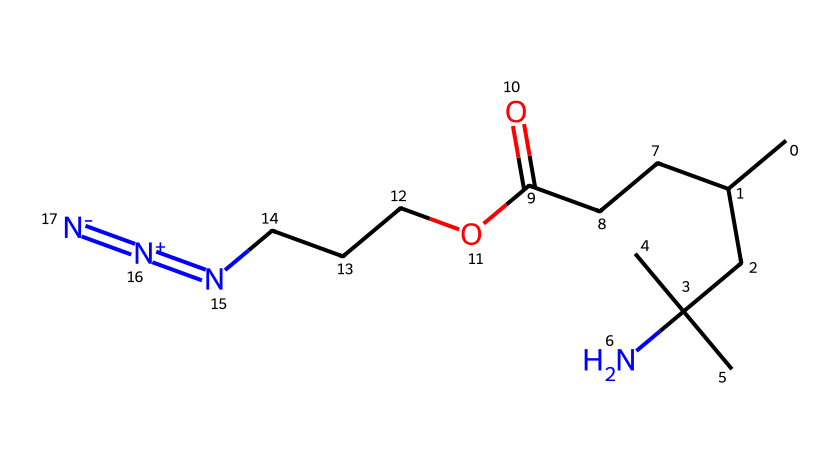What is the total number of carbon atoms in the chemical? By visual inspection of the SMILES representation, count all the carbon atoms present in the structural formula. There are four carbon atoms in the substituent group connected to nitrogen and a chain of carbon atoms leading up to the carbonyl group, plus there are two more carbon atoms in the ethyl part of the ester and one more from the azide group, totaling eight carbon atoms.
Answer: eight How many nitrogen atoms are present in this compound? In the provided SMILES, identify the nitrogen atoms. The azide functional group ([N+]=[N-]), which appears at the end of the structure, contains three nitrogen atoms. Additionally, another nitrogen atom is attached to the bulky amine group, giving a total of four nitrogen atoms.
Answer: four What type of functional group is represented by "N=[N+]=[N-]"? The notation indicates a linear azide functional group characterized by the presence of multiple nitrogen atoms in a specific bonding arrangement. The structure shows that it contains one positive charge and one negative charge, which is typical in azides.
Answer: azide Is this polymer likely to be hydrophilic or hydrophobic? Analyzing the presence of functional groups reveals that the compound has a hydrophilic carboxylic acid (-COOH) and a nitrogen-containing group. These polar functional groups suggest that the polymer would be more likely to interact favorably with water, indicating hydrophilicity.
Answer: hydrophilic What is the significance of the azide group in smart textiles? The azide group is known for its unique reactivity, particularly in click chemistry, which allows for easy attachment to other materials and functionalities. This makes azide-functionalized polymers particularly valuable for creating smart textiles that can change properties or respond to stimuli.
Answer: reactivity What kind of polymerization method could be used to create azide-functionalized polymers? Given the presence of the azide group in the chemical structure, methods like "click chemistry" or "chain-growth polymerization" could be applied due to the efficiency and specificity associated with azide reactions, ensuring effective integration in textile applications.
Answer: click chemistry 